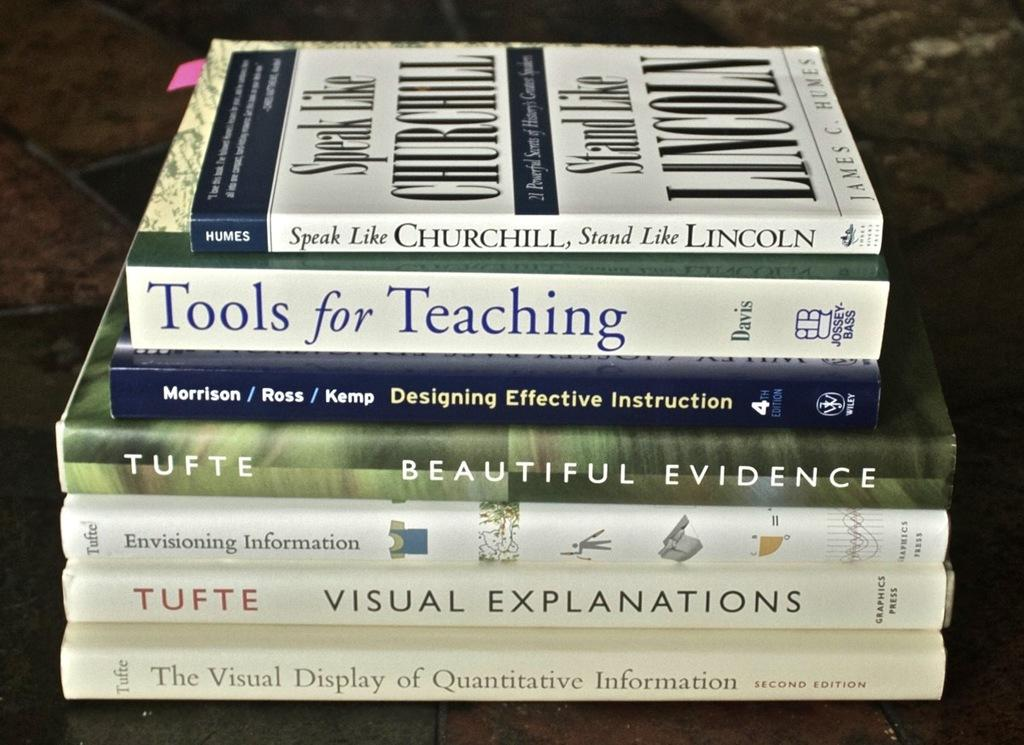Provide a one-sentence caption for the provided image. a couple books used for learning and understanding different aspects of life. 